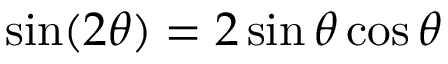Convert formula to latex. <formula><loc_0><loc_0><loc_500><loc_500>\sin ( 2 \theta ) = 2 \sin \theta \cos \theta</formula> 